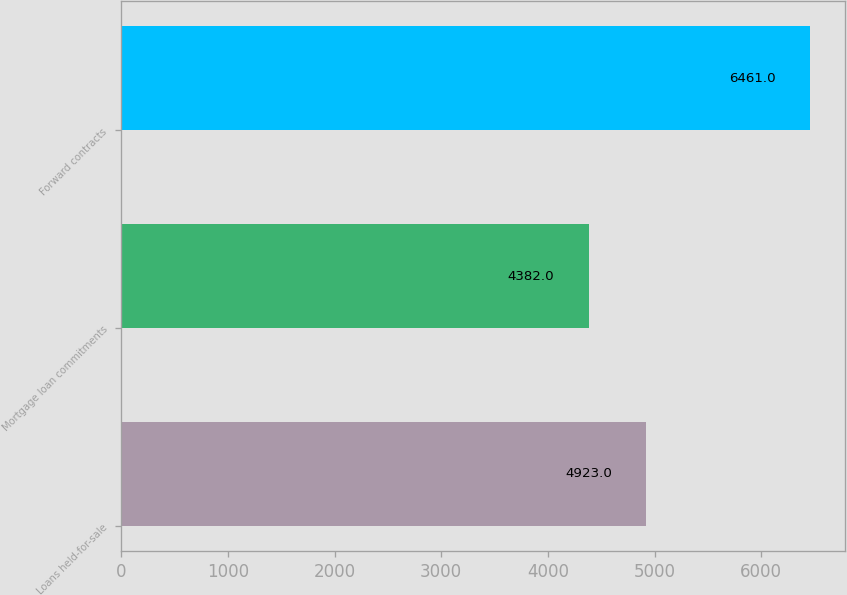Convert chart to OTSL. <chart><loc_0><loc_0><loc_500><loc_500><bar_chart><fcel>Loans held-for-sale<fcel>Mortgage loan commitments<fcel>Forward contracts<nl><fcel>4923<fcel>4382<fcel>6461<nl></chart> 